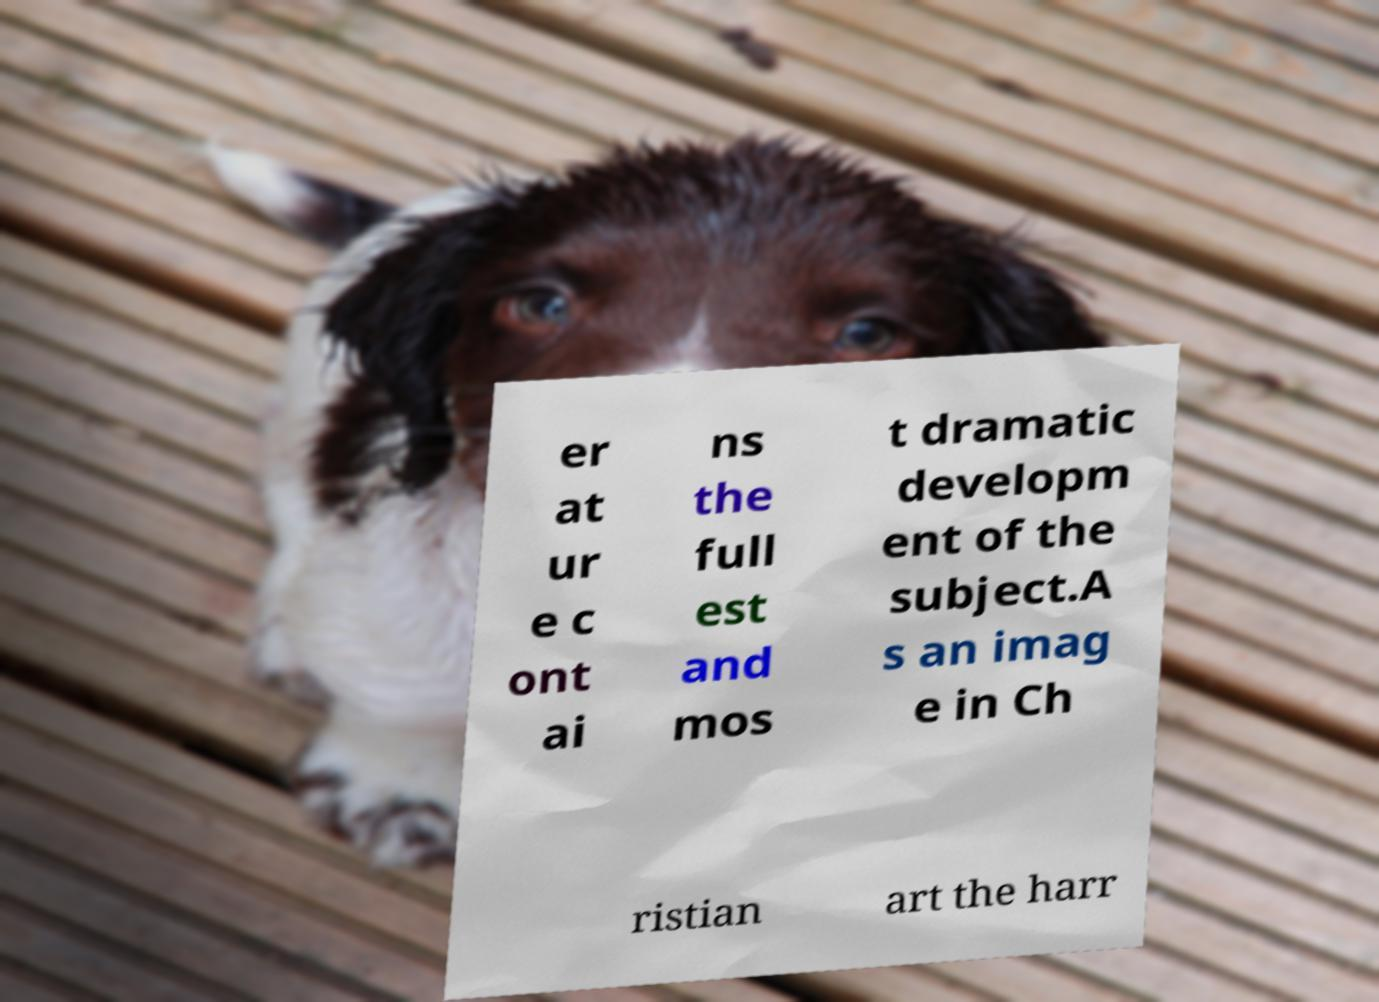Please identify and transcribe the text found in this image. er at ur e c ont ai ns the full est and mos t dramatic developm ent of the subject.A s an imag e in Ch ristian art the harr 